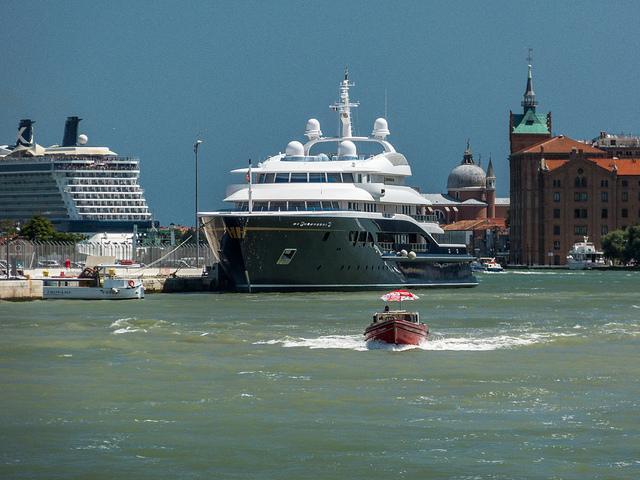How many boats are there?
Give a very brief answer. 3. 